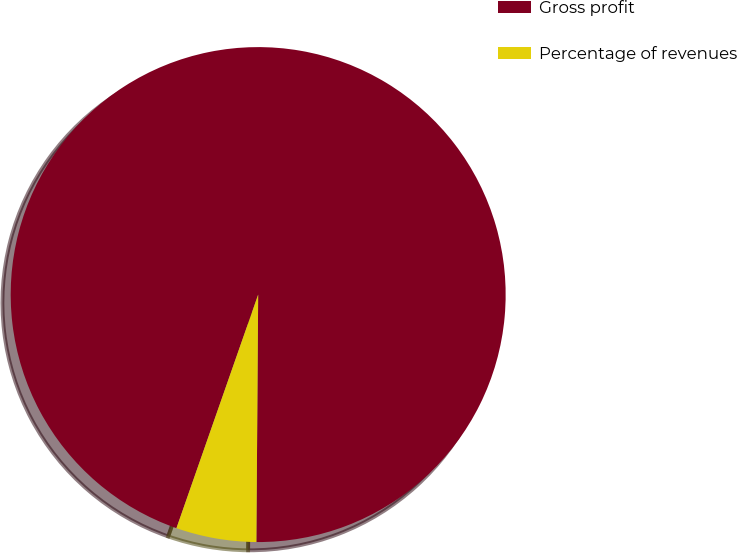Convert chart to OTSL. <chart><loc_0><loc_0><loc_500><loc_500><pie_chart><fcel>Gross profit<fcel>Percentage of revenues<nl><fcel>94.76%<fcel>5.24%<nl></chart> 